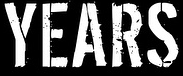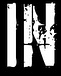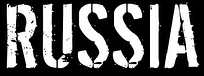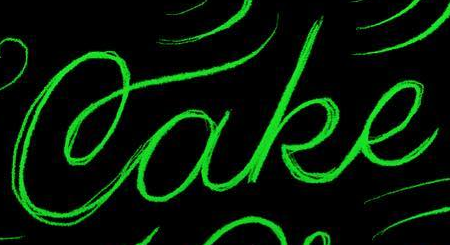What text appears in these images from left to right, separated by a semicolon? YEARS; IN; RUSSIA; Cake 